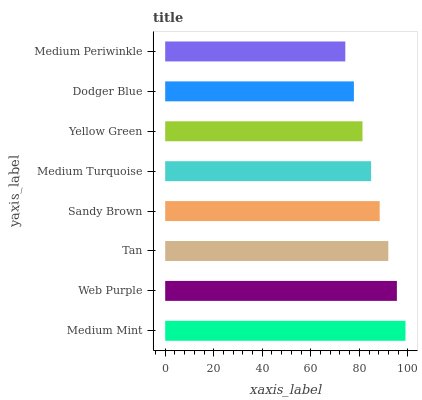Is Medium Periwinkle the minimum?
Answer yes or no. Yes. Is Medium Mint the maximum?
Answer yes or no. Yes. Is Web Purple the minimum?
Answer yes or no. No. Is Web Purple the maximum?
Answer yes or no. No. Is Medium Mint greater than Web Purple?
Answer yes or no. Yes. Is Web Purple less than Medium Mint?
Answer yes or no. Yes. Is Web Purple greater than Medium Mint?
Answer yes or no. No. Is Medium Mint less than Web Purple?
Answer yes or no. No. Is Sandy Brown the high median?
Answer yes or no. Yes. Is Medium Turquoise the low median?
Answer yes or no. Yes. Is Medium Mint the high median?
Answer yes or no. No. Is Medium Mint the low median?
Answer yes or no. No. 